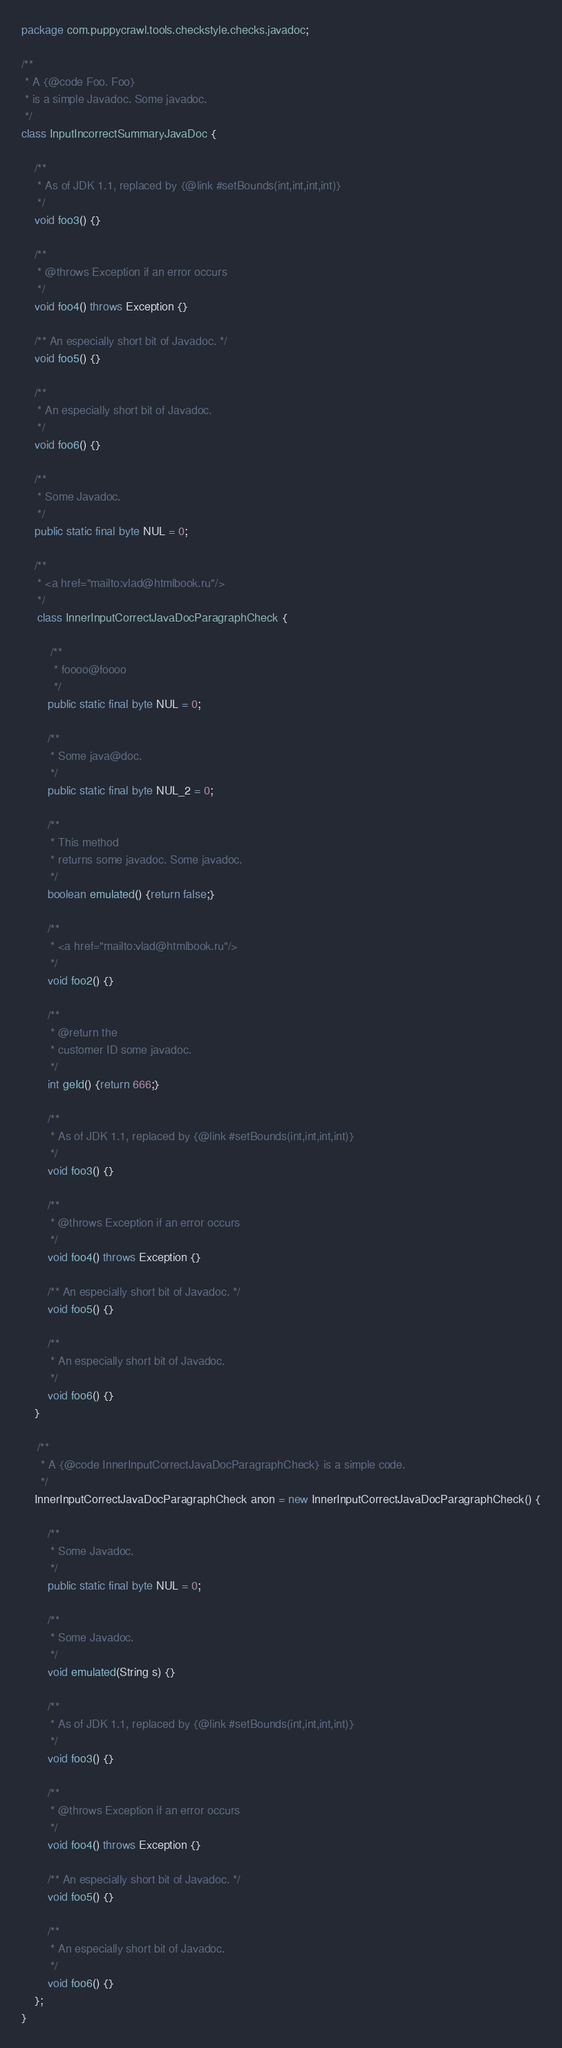<code> <loc_0><loc_0><loc_500><loc_500><_Java_>package com.puppycrawl.tools.checkstyle.checks.javadoc;

/**
 * A {@code Foo. Foo}
 * is a simple Javadoc. Some javadoc.
 */
class InputIncorrectSummaryJavaDoc {
    
    /**
     * As of JDK 1.1, replaced by {@link #setBounds(int,int,int,int)}
     */
    void foo3() {}
    
    /**
     * @throws Exception if an error occurs
     */
    void foo4() throws Exception {}
    
    /** An especially short bit of Javadoc. */
    void foo5() {}

    /**
     * An especially short bit of Javadoc.
     */
    void foo6() {}

    /**
     * Some Javadoc.
     */
    public static final byte NUL = 0;

    /** 
     * <a href="mailto:vlad@htmlbook.ru"/> 
     */
     class InnerInputCorrectJavaDocParagraphCheck {

         /**
          * foooo@foooo
          */
        public static final byte NUL = 0;

        /** 
         * Some java@doc.
         */
        public static final byte NUL_2 = 0;

        /**
         * This method
         * returns some javadoc. Some javadoc.
         */
        boolean emulated() {return false;}
        
        /**
         * <a href="mailto:vlad@htmlbook.ru"/>
         */
        void foo2() {}

        /**
         * @return the
         * customer ID some javadoc.
         */
        int geId() {return 666;} 

        /**
         * As of JDK 1.1, replaced by {@link #setBounds(int,int,int,int)}
         */
        void foo3() {}
        
        /**
         * @throws Exception if an error occurs
         */
        void foo4() throws Exception {}
        
        /** An especially short bit of Javadoc. */
        void foo5() {}

        /**
         * An especially short bit of Javadoc.
         */
        void foo6() {}
    }

     /**
      * A {@code InnerInputCorrectJavaDocParagraphCheck} is a simple code.
      */
    InnerInputCorrectJavaDocParagraphCheck anon = new InnerInputCorrectJavaDocParagraphCheck() {

        /**
         * Some Javadoc.
         */
        public static final byte NUL = 0;

        /**
         * Some Javadoc.
         */
        void emulated(String s) {}
        
        /**
         * As of JDK 1.1, replaced by {@link #setBounds(int,int,int,int)}
         */
        void foo3() {}
        
        /**
         * @throws Exception if an error occurs
         */
        void foo4() throws Exception {}
        
        /** An especially short bit of Javadoc. */
        void foo5() {}

        /**
         * An especially short bit of Javadoc.
         */
        void foo6() {}
    };
}
</code> 